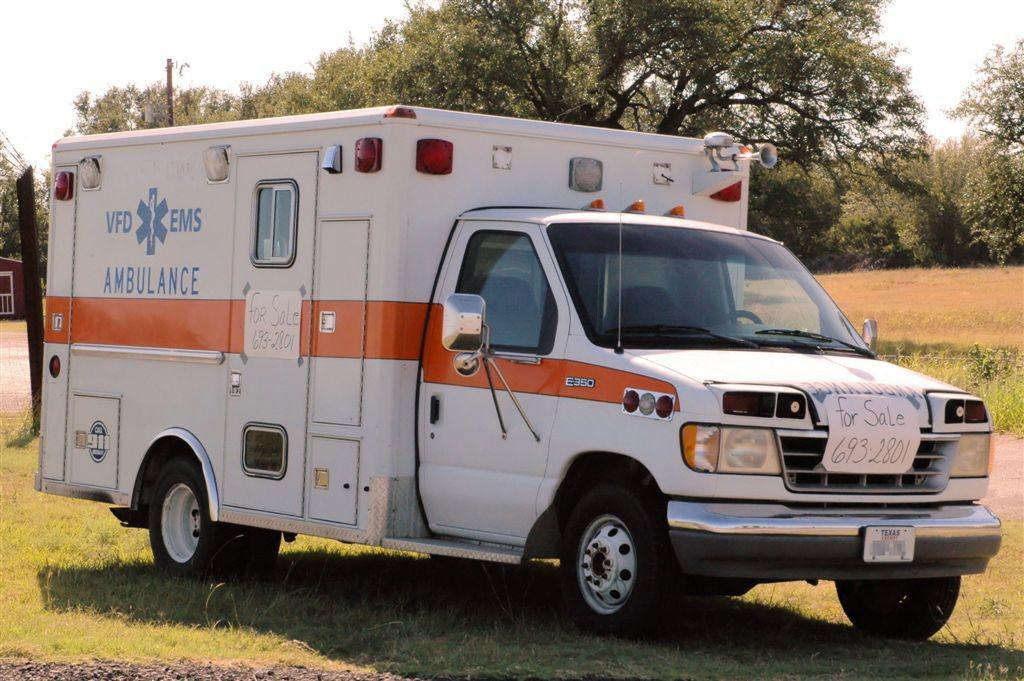<image>
Provide a brief description of the given image. The sign on the front of the ambulance indicates it is for sale and provides a contact phone number. 